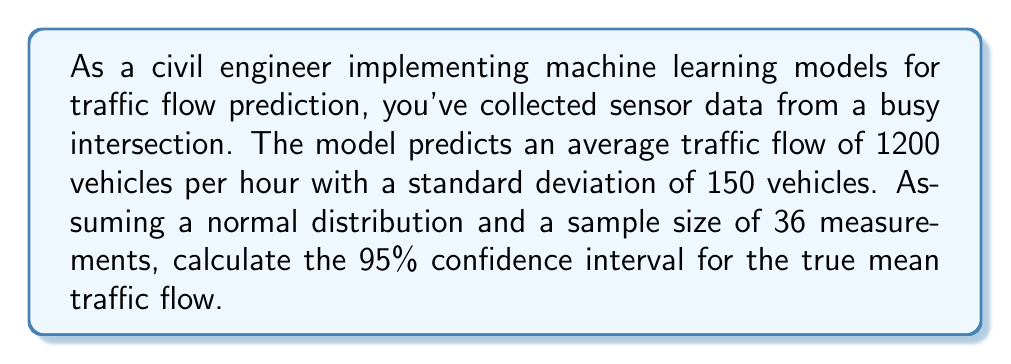Provide a solution to this math problem. To calculate the confidence interval, we'll follow these steps:

1. Identify the known values:
   - Sample mean ($\bar{x}$) = 1200 vehicles/hour
   - Sample standard deviation ($s$) = 150 vehicles/hour
   - Sample size ($n$) = 36
   - Confidence level = 95% (α = 0.05)

2. Determine the critical value ($t$):
   For a 95% confidence interval with 35 degrees of freedom (n-1), the t-value is approximately 2.030 (from t-distribution table).

3. Calculate the standard error ($SE$):
   $$SE = \frac{s}{\sqrt{n}} = \frac{150}{\sqrt{36}} = 25$$

4. Compute the margin of error ($ME$):
   $$ME = t \cdot SE = 2.030 \cdot 25 = 50.75$$

5. Calculate the confidence interval:
   Lower bound: $\bar{x} - ME = 1200 - 50.75 = 1149.25$
   Upper bound: $\bar{x} + ME = 1200 + 50.75 = 1250.75$

Therefore, the 95% confidence interval for the true mean traffic flow is (1149.25, 1250.75) vehicles per hour.
Answer: (1149.25, 1250.75) vehicles/hour 